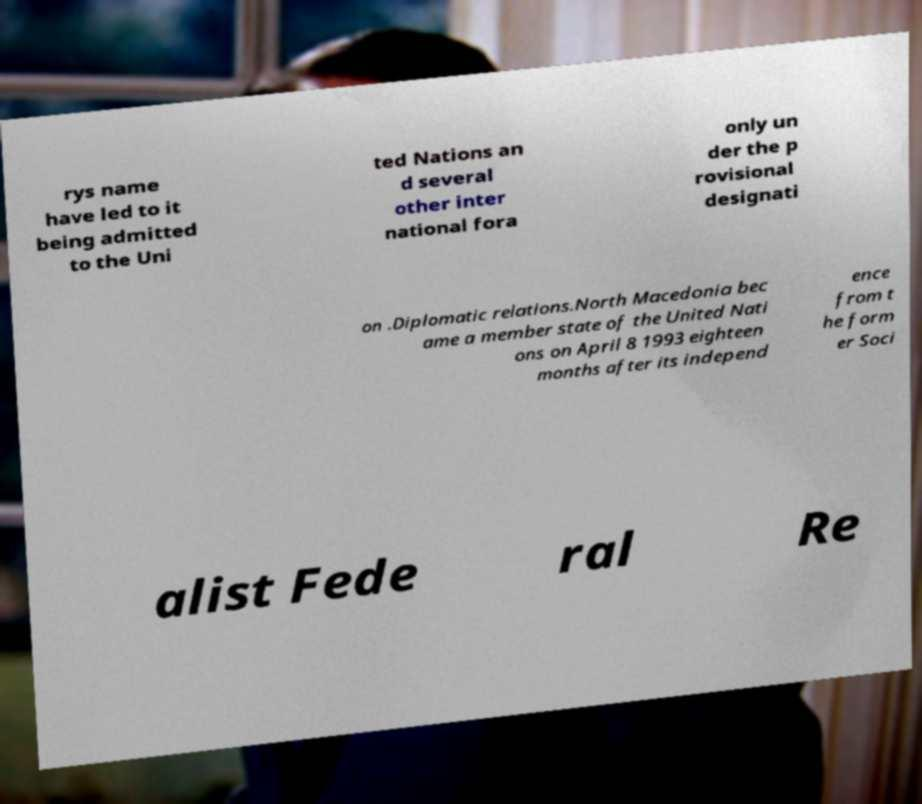For documentation purposes, I need the text within this image transcribed. Could you provide that? rys name have led to it being admitted to the Uni ted Nations an d several other inter national fora only un der the p rovisional designati on .Diplomatic relations.North Macedonia bec ame a member state of the United Nati ons on April 8 1993 eighteen months after its independ ence from t he form er Soci alist Fede ral Re 